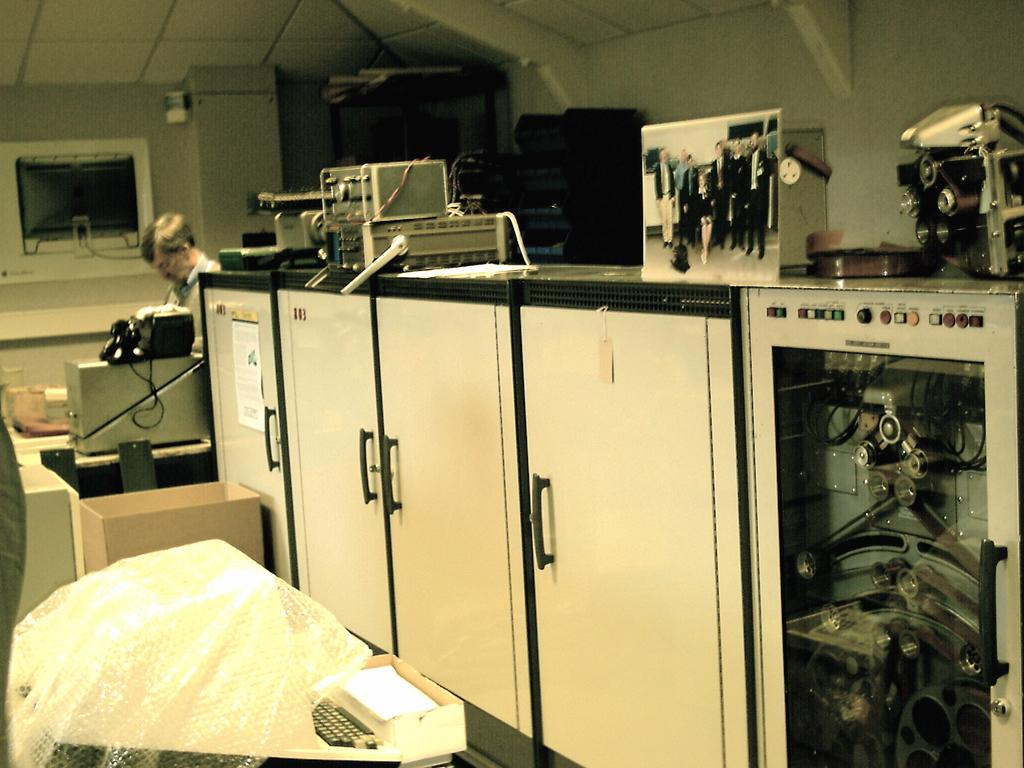What is the main subject of the image? There is a person standing in the image. What can be seen on the table in the image? There are electronic items on the table in the image. What type of furniture is present in the image? There is a wardrobe in the image. What grade did the person in the image receive on their last exam? There is no information about the person's grades or exams in the image. 